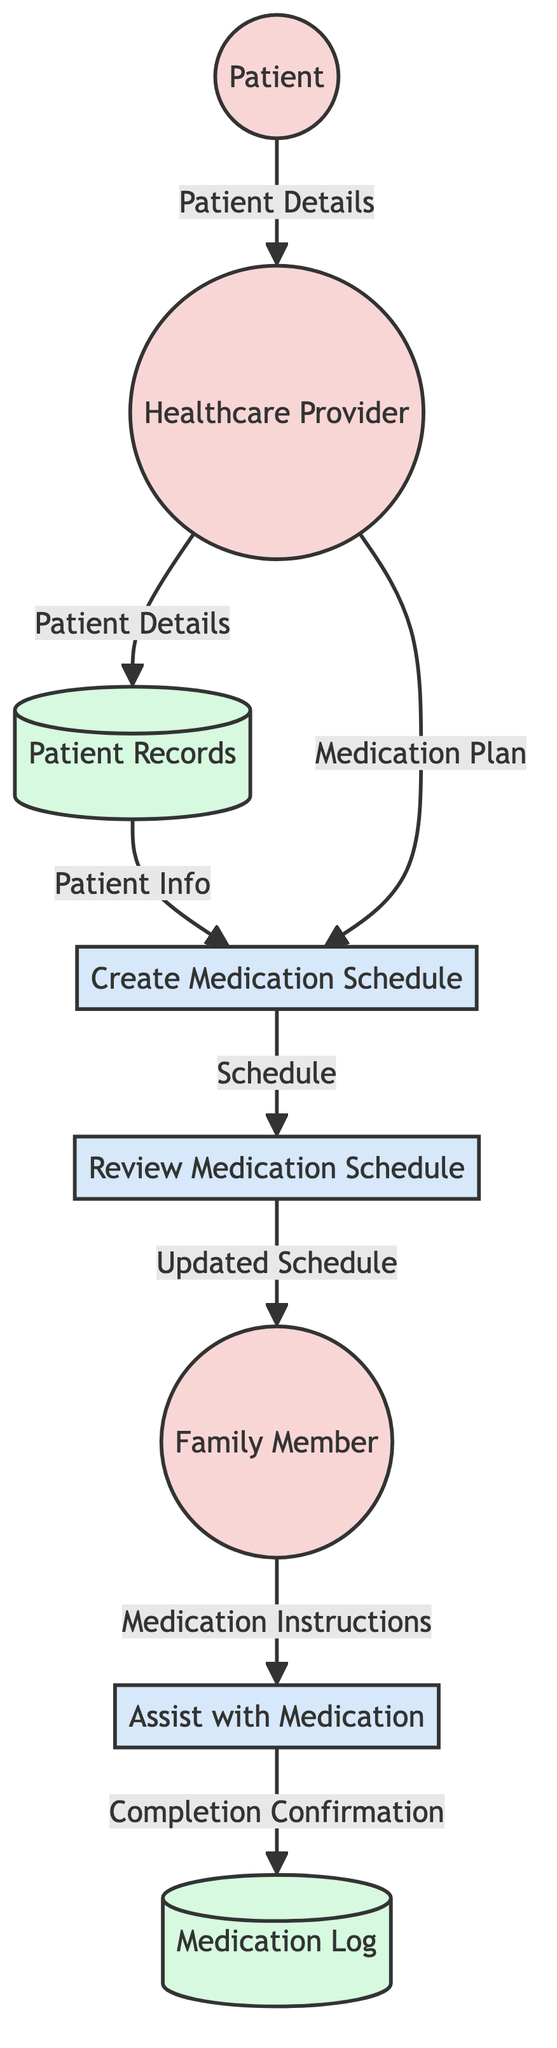What is the purpose of the "Create Medication Schedule" process? The "Create Medication Schedule" process is responsible for setting up the patient's daily medication schedule by taking inputs from the Patient, Medication, and Healthcare Provider. This indicates that its function is to generate a detailed plan for when the patient should take each medication.
Answer: Setup the patient's daily medication schedule Who assists the patient with medication intake? The diagram indicates that a Family Member is responsible for assisting the patient with medication intake, as this entity is directly connected to the "Assist with Medication" process.
Answer: Family Member How many entities are present in the diagram? The diagram shows three entities: Patient, Healthcare Provider, and Family Member. By counting these distinct entities, we find that there are a total of three.
Answer: Three What is generated as an output from the "Review Medication Schedule" process? The "Review Medication Schedule" process takes in the Schedule as input and outputs an Updated Schedule, which reflects any changes or reviews made during the process.
Answer: Updated Schedule What do the Patient Records store? Patient Records store patient-related data, including Patient Details, Medical History, and Current Medications as attributes, which provide a comprehensive snapshot of the patient's information for healthcare providers.
Answer: Patient Details, Medical History, Current Medications How does the Family Member receive the Medication Instructions? The Family Member receives the Medication Instructions as output from the Schedule, which is generated by the "Create Medication Schedule" process, illustrating the flow of information for assisting the patient effectively.
Answer: From the Schedule What is the final output of the "Assist with Medication" process? The final output of the "Assist with Medication" process is the Completion Confirmation, which logs that the patient has taken their medication as per the schedule followed by the family member's assistance.
Answer: Completion Confirmation What flows from the Healthcare Provider to the Patient Records? The Healthcare Provider transmits Patient Details to the Patient Records, which is essential for storing all relevant information about the patient and their medication plan in the system.
Answer: Patient Details What are the attributes of the Medication entity? The Medication entity includes attributes such as Name, Dosage, and Frequency, which provide specific details about the medications assigned to the patient.
Answer: Name, Dosage, Frequency 